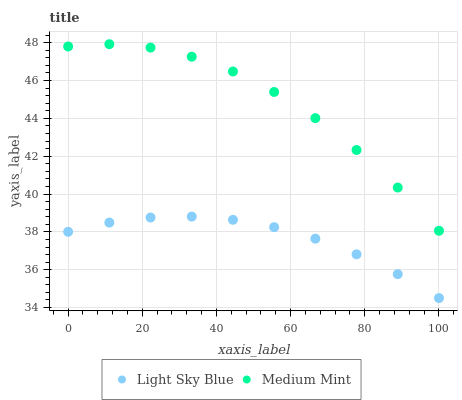Does Light Sky Blue have the minimum area under the curve?
Answer yes or no. Yes. Does Medium Mint have the maximum area under the curve?
Answer yes or no. Yes. Does Light Sky Blue have the maximum area under the curve?
Answer yes or no. No. Is Light Sky Blue the smoothest?
Answer yes or no. Yes. Is Medium Mint the roughest?
Answer yes or no. Yes. Is Light Sky Blue the roughest?
Answer yes or no. No. Does Light Sky Blue have the lowest value?
Answer yes or no. Yes. Does Medium Mint have the highest value?
Answer yes or no. Yes. Does Light Sky Blue have the highest value?
Answer yes or no. No. Is Light Sky Blue less than Medium Mint?
Answer yes or no. Yes. Is Medium Mint greater than Light Sky Blue?
Answer yes or no. Yes. Does Light Sky Blue intersect Medium Mint?
Answer yes or no. No. 